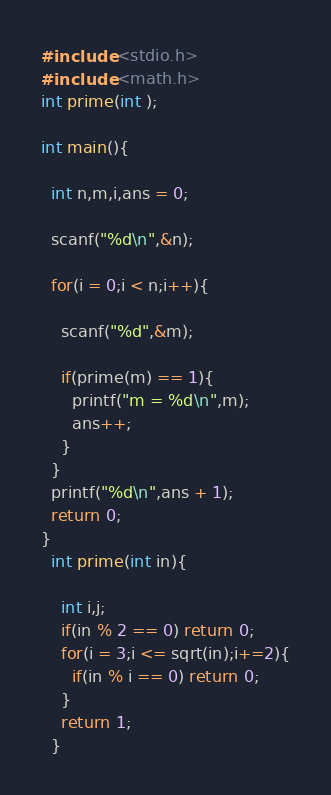<code> <loc_0><loc_0><loc_500><loc_500><_C_>#include <stdio.h>
#include <math.h>
int prime(int );

int main(){

  int n,m,i,ans = 0;

  scanf("%d\n",&n);

  for(i = 0;i < n;i++){

    scanf("%d",&m);

    if(prime(m) == 1){
      printf("m = %d\n",m);
      ans++;
    }
  }
  printf("%d\n",ans + 1);
  return 0;
}
  int prime(int in){

    int i,j;
    if(in % 2 == 0) return 0;
    for(i = 3;i <= sqrt(in);i+=2){
      if(in % i == 0) return 0;
    }
    return 1;
  }</code> 